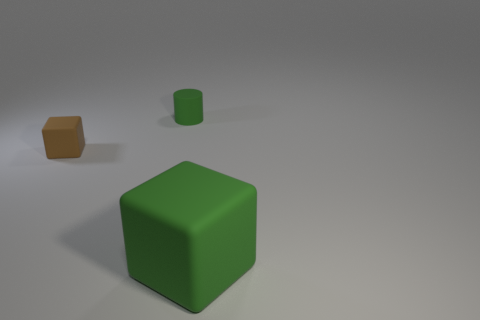Add 2 small cyan cylinders. How many objects exist? 5 Subtract all cubes. How many objects are left? 1 Subtract all green cubes. How many cubes are left? 1 Add 1 small blue cubes. How many small blue cubes exist? 1 Subtract 0 red blocks. How many objects are left? 3 Subtract all cyan cubes. Subtract all brown cylinders. How many cubes are left? 2 Subtract all red spheres. How many green cubes are left? 1 Subtract all green shiny spheres. Subtract all cylinders. How many objects are left? 2 Add 1 small green matte things. How many small green matte things are left? 2 